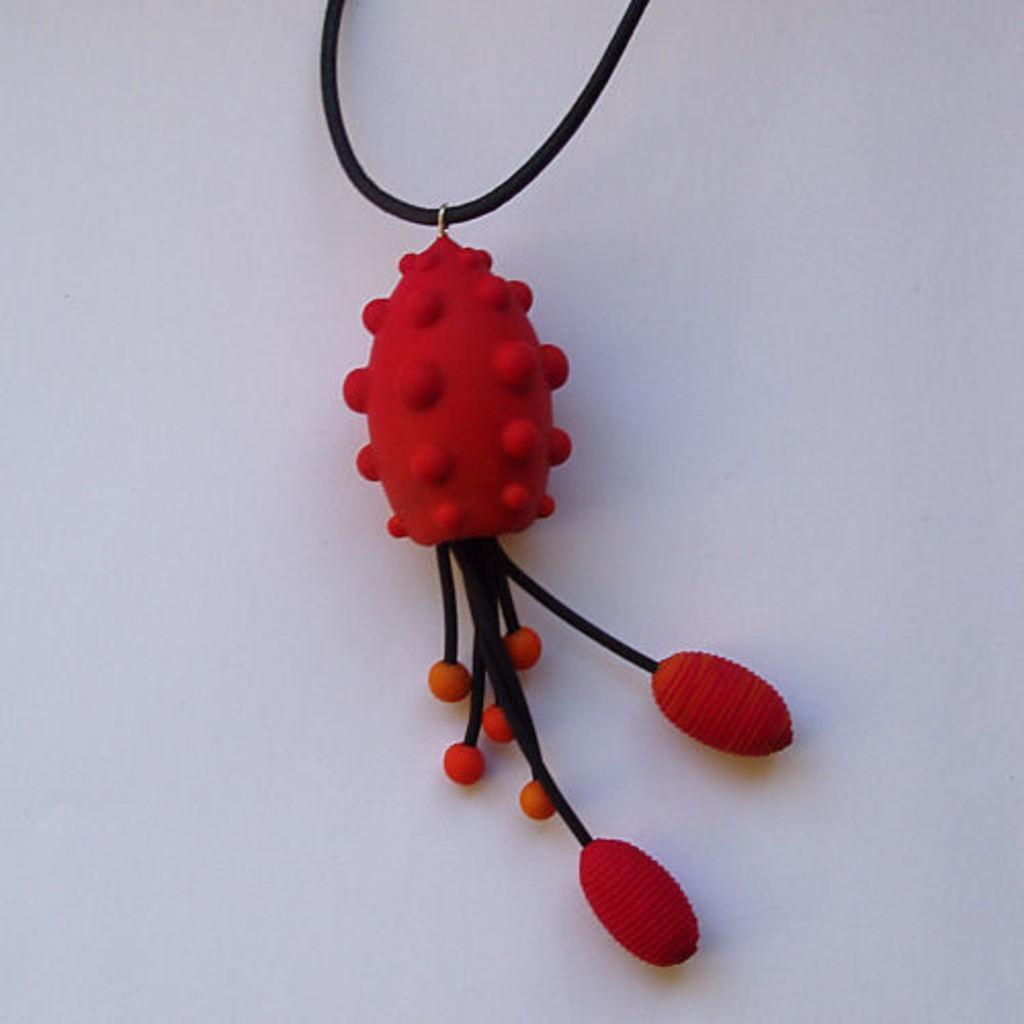In one or two sentences, can you explain what this image depicts? In this image, we can see a locket and the background. 